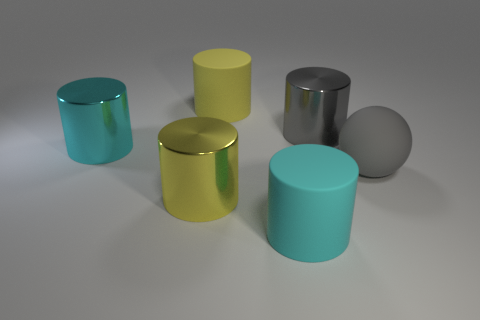Subtract all yellow cylinders. How many cylinders are left? 3 Add 1 gray shiny cylinders. How many objects exist? 7 Subtract all green spheres. How many yellow cylinders are left? 2 Subtract all balls. How many objects are left? 5 Subtract 1 balls. How many balls are left? 0 Subtract all yellow cylinders. How many cylinders are left? 3 Subtract all green spheres. Subtract all brown cubes. How many spheres are left? 1 Subtract all gray cylinders. Subtract all matte balls. How many objects are left? 4 Add 1 shiny cylinders. How many shiny cylinders are left? 4 Add 5 big gray spheres. How many big gray spheres exist? 6 